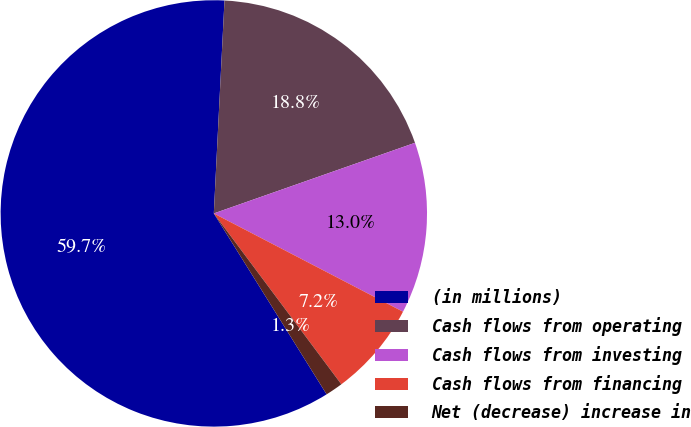Convert chart to OTSL. <chart><loc_0><loc_0><loc_500><loc_500><pie_chart><fcel>(in millions)<fcel>Cash flows from operating<fcel>Cash flows from investing<fcel>Cash flows from financing<fcel>Net (decrease) increase in<nl><fcel>59.67%<fcel>18.83%<fcel>13.0%<fcel>7.17%<fcel>1.33%<nl></chart> 